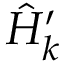Convert formula to latex. <formula><loc_0><loc_0><loc_500><loc_500>\hat { H } _ { k } ^ { \prime }</formula> 